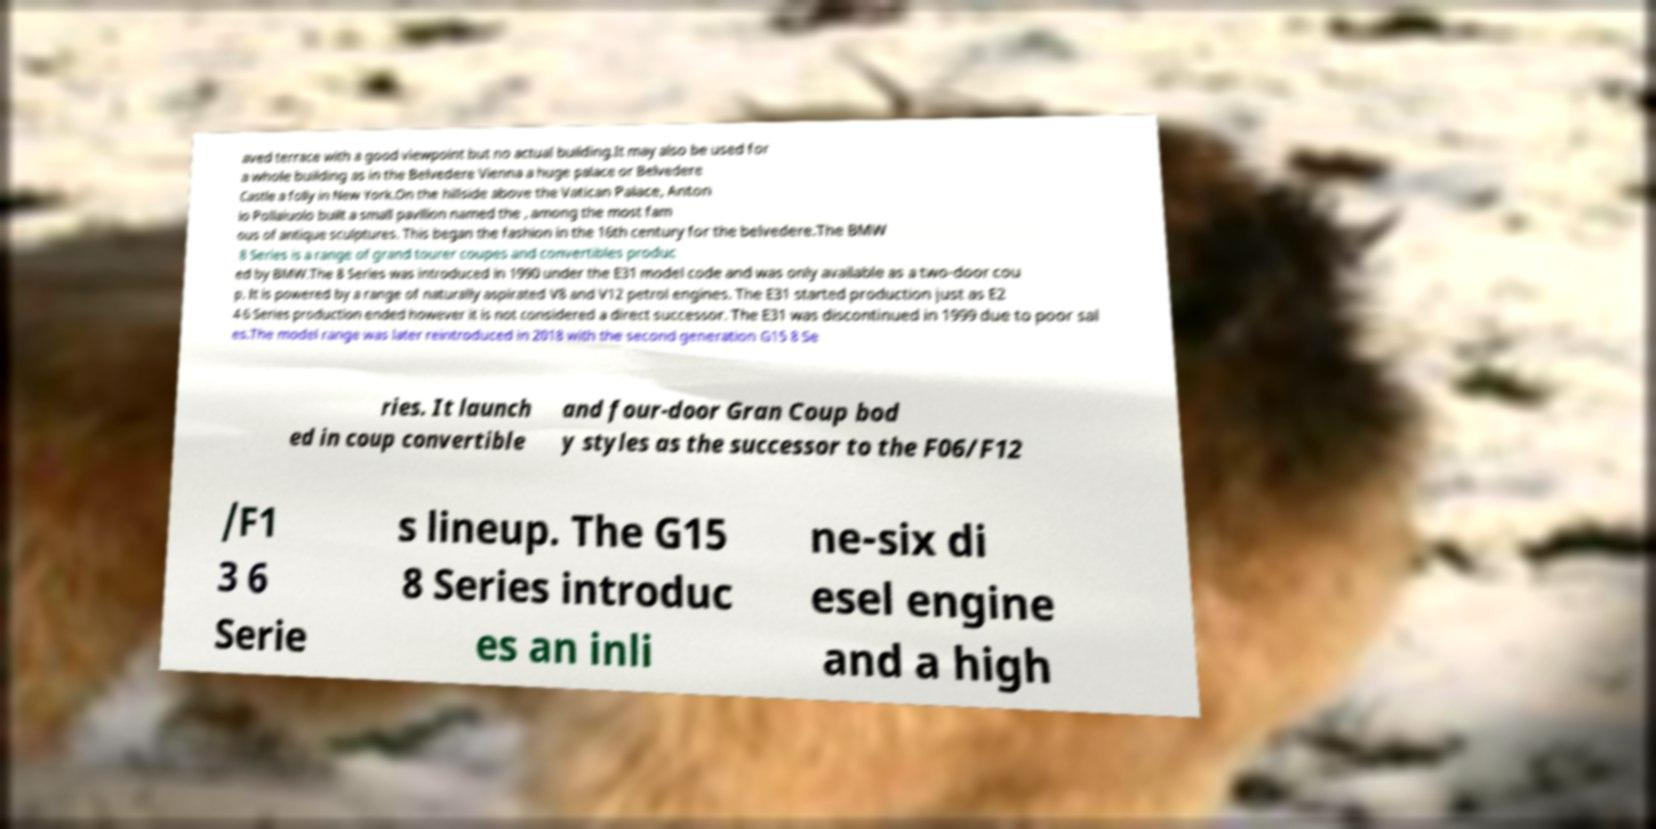Please read and relay the text visible in this image. What does it say? aved terrace with a good viewpoint but no actual building.It may also be used for a whole building as in the Belvedere Vienna a huge palace or Belvedere Castle a folly in New York.On the hillside above the Vatican Palace, Anton io Pollaiuolo built a small pavilion named the , among the most fam ous of antique sculptures. This began the fashion in the 16th century for the belvedere.The BMW 8 Series is a range of grand tourer coupes and convertibles produc ed by BMW.The 8 Series was introduced in 1990 under the E31 model code and was only available as a two-door cou p. It is powered by a range of naturally aspirated V8 and V12 petrol engines. The E31 started production just as E2 4 6 Series production ended however it is not considered a direct successor. The E31 was discontinued in 1999 due to poor sal es.The model range was later reintroduced in 2018 with the second generation G15 8 Se ries. It launch ed in coup convertible and four-door Gran Coup bod y styles as the successor to the F06/F12 /F1 3 6 Serie s lineup. The G15 8 Series introduc es an inli ne-six di esel engine and a high 